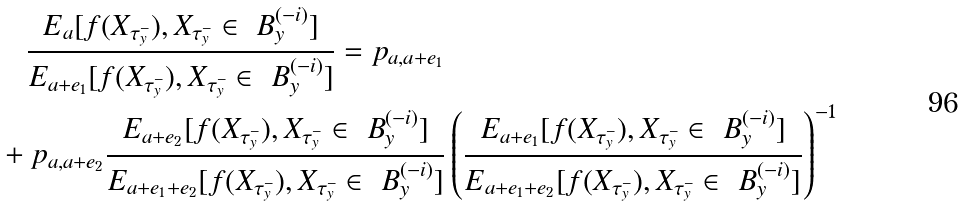Convert formula to latex. <formula><loc_0><loc_0><loc_500><loc_500>& \quad \frac { { E _ { a } [ f ( X _ { \tau ^ { - } _ { y } } ) , X _ { \tau ^ { - } _ { y } } \in \ B ^ { ( - i ) } _ { y } ] } } { { E _ { a + e _ { 1 } } [ f ( X _ { \tau ^ { - } _ { y } } ) , X _ { \tau ^ { - } _ { y } } \in \ B ^ { ( - i ) } _ { y } ] } } = p _ { a , a + e _ { 1 } } \\ & + p _ { a , a + e _ { 2 } } \frac { { E _ { a + e _ { 2 } } [ f ( X _ { \tau ^ { - } _ { y } } ) , X _ { \tau ^ { - } _ { y } } \in \ B ^ { ( - i ) } _ { y } ] } } { { E _ { a + e _ { 1 } + e _ { 2 } } [ f ( X _ { \tau ^ { - } _ { y } } ) , X _ { \tau ^ { - } _ { y } } \in \ B ^ { ( - i ) } _ { y } ] } } \left ( \frac { { E _ { a + e _ { 1 } } [ f ( X _ { \tau ^ { - } _ { y } } ) , X _ { \tau ^ { - } _ { y } } \in \ B ^ { ( - i ) } _ { y } ] } } { { E _ { a + e _ { 1 } + e _ { 2 } } [ f ( X _ { \tau ^ { - } _ { y } } ) , X _ { \tau ^ { - } _ { y } } \in \ B ^ { ( - i ) } _ { y } ] } } \right ) ^ { - 1 }</formula> 